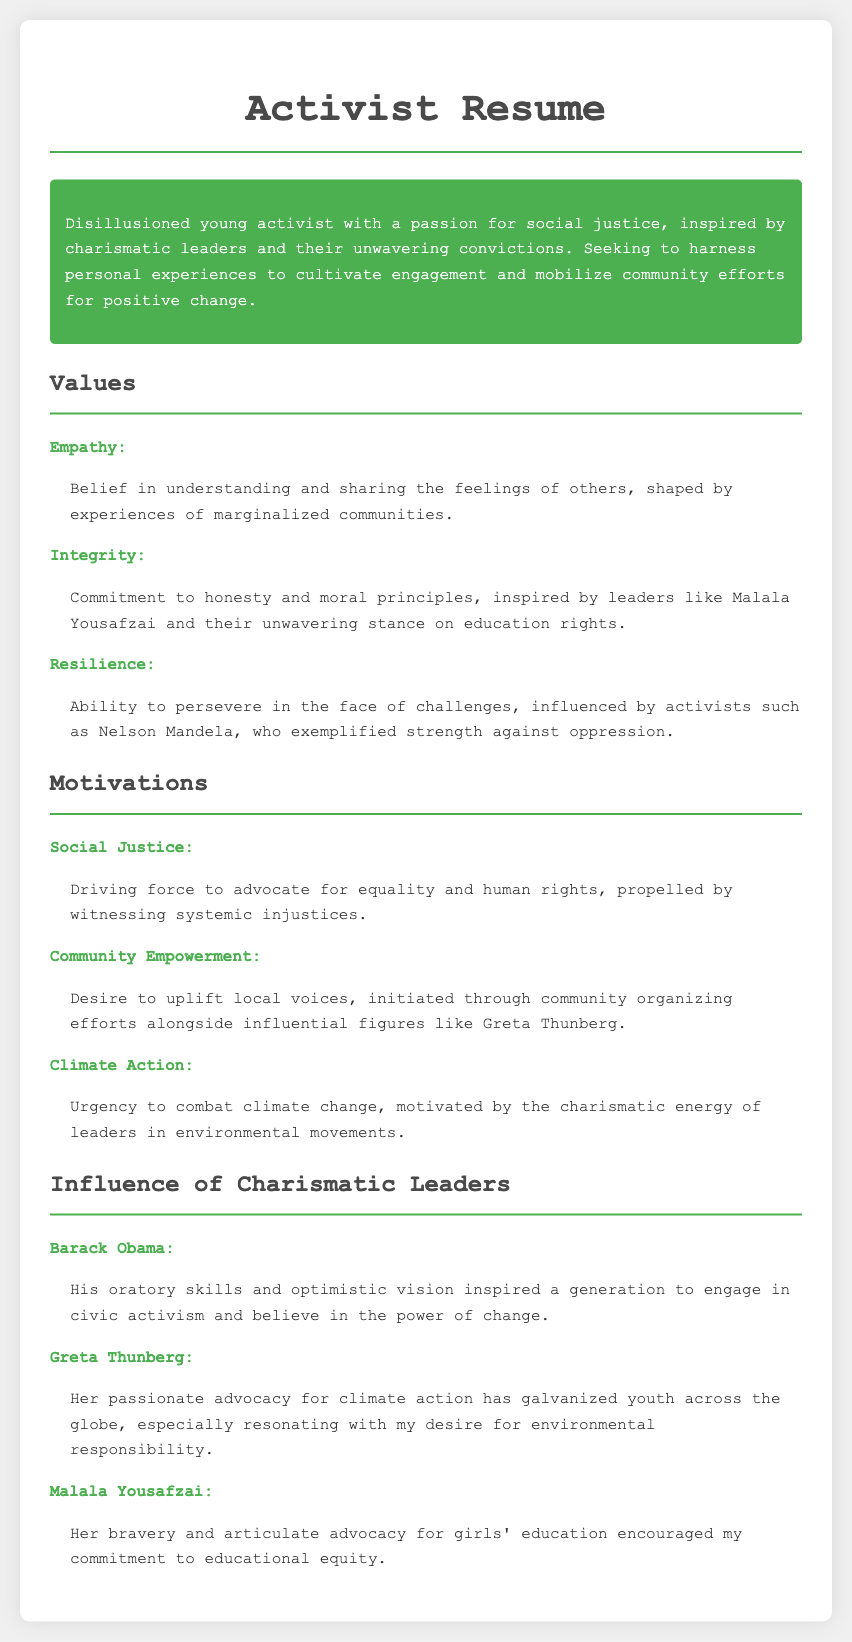What are the core values listed? The core values are a key part of the personal statement, which include Empathy, Integrity, and Resilience.
Answer: Empathy, Integrity, Resilience Who is the activist inspired by regarding education rights? The document mentions Malala Yousafzai as an influential leader regarding education rights.
Answer: Malala Yousafzai What motivates the activist to advocate for social justice? The motivation for social justice stems from witnessing systemic injustices.
Answer: Witnessing systemic injustices Which charismatic leader is associated with climate action? Greta Thunberg is directly referenced in relation to climate action in the document.
Answer: Greta Thunberg What leadership quality of Barack Obama inspired activism? Barack Obama is noted for his oratory skills as an inspiring quality for civic activism.
Answer: Oratory skills Which section discusses personal motivations? The section titled "Motivations" covers the activist's driving forces.
Answer: Motivations How many charismatic leaders are mentioned influencing the activism? Three charismatic leaders are mentioned in the section about their influence.
Answer: Three What type of activism does the activist seek to cultivate? The activist looks to cultivate engagement and mobilize community efforts for change.
Answer: Engagement and mobilize community efforts 